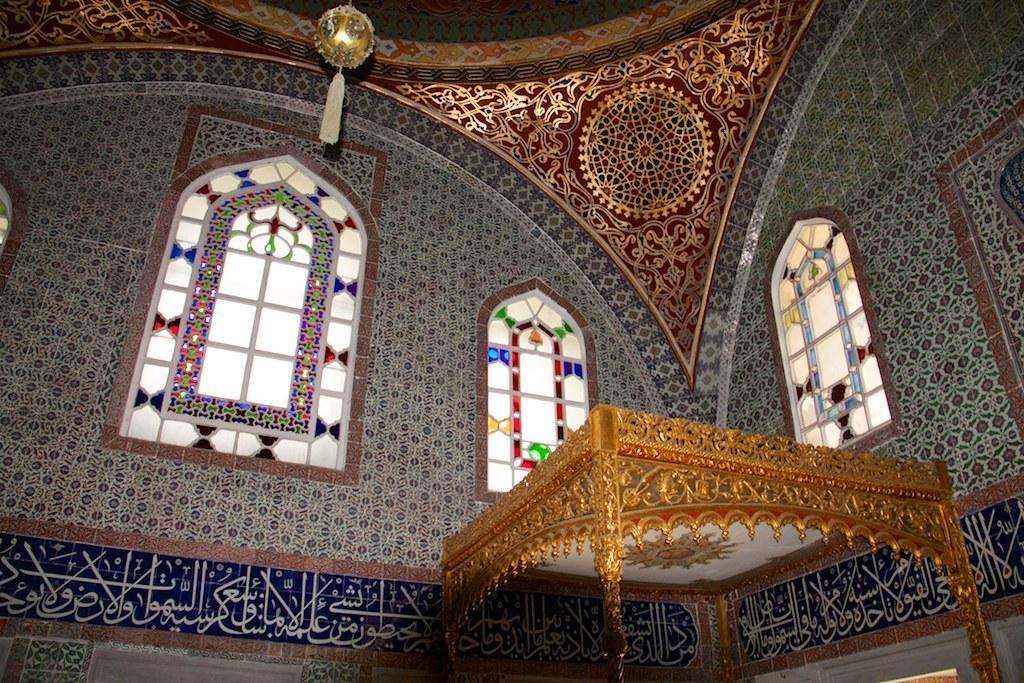Please provide a concise description of this image. In this picture we see the interior of a mosque with big windows and Arabic written on the walls. 